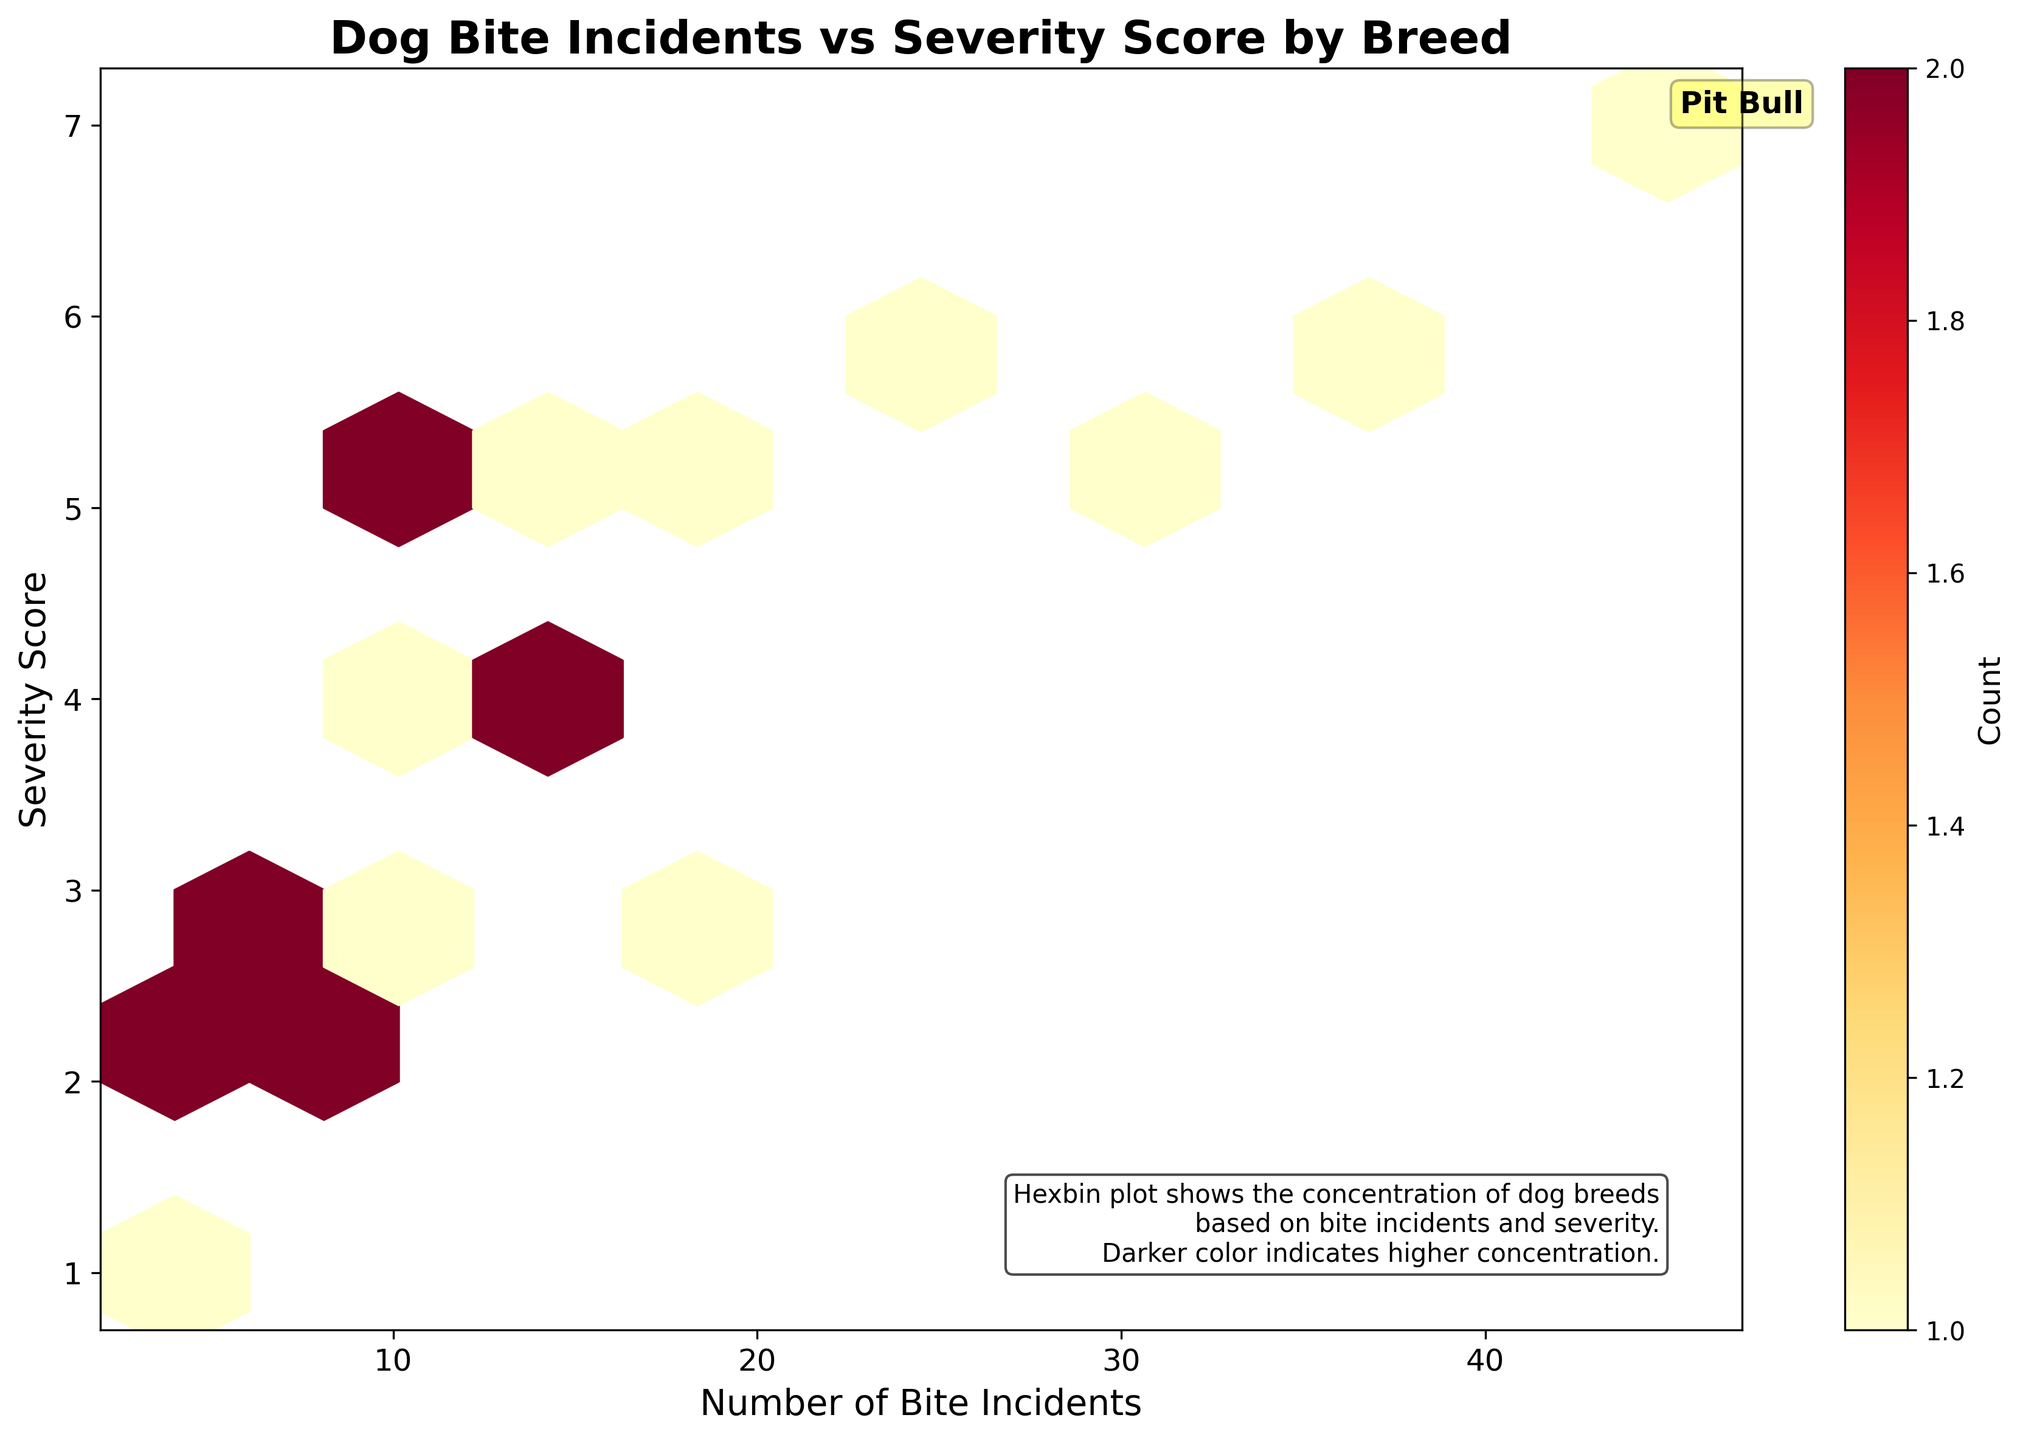what is the title of the plot? The title of the plot is displayed at the top of the figure in bold font. It reads "Dog Bite Incidents vs Severity Score by Breed".
Answer: Dog Bite Incidents vs Severity Score by Breed How many hexagons are there in the grid? To determine the number of hexagons, we note that the hexbin grid size parameter is set to 10, which is a typical dimension for small hexbin plots.
Answer: 10x10 grid Which breed is specifically annotated in the plot? The annotation specifically points to the 'Pit Bull' breed. The annotation includes the text 'Pit Bull' and is placed near its data point to highlight its significant bite incidents and severity score.
Answer: Pit Bull How many dog breeds have a severity score of 5 and higher? By inspecting the hexbin plot, focus on the y-axis to identify breeds with a severity score of 5 and higher. Count the data points within hexagons at or above that level.
Answer: 8 breeds What is the highest number of bite incidents recorded by any breed? Look at the x-axis (Number of Bite Incidents) and identify the furthest data point to the right. The maximum value corresponds to the 'Pit Bull' breed with 45 incidents.
Answer: 45 How does the number of bite incidents by Labradors compare to Pit Bulls? Locate both Labradors and Pit Bulls on the hexbin plot. Labradors have 30 bite incidents, and Pit Bulls have 45. Compare these two figures.
Answer: Labradors have fewer bite incidents compared to Pit Bulls What is the average severity score among breeds with 10 or more bite incidents? First, identify the breeds with 10 or more bite incidents: Pit Bull, Labrador Retriever, German Shepherd, Rottweiler, Chihuahua, Boxer, and Great Dane. Sum their severity scores (7 + 5 + 6 + 6 + 3 + 4 + 5 = 36) and divide by the number of breeds (36 / 7).
Answer: 5.14 Which breeds have a severity score that exceeds that of the Labrador Retriever? The severity score of the Labrador Retriever is 5. Compare it with other breeds' severity scores: Pit Bull (7), German Shepherd (6), Rottweiler (6). These exceeding scores suggest that they have more severe incidents.
Answer: Pit Bull, German Shepherd, Rottweiler What does the color intensity in hexagons indicate? The color intensity (darker color) represents the number of data points in that area, showing where bite incidents and severity scores cluster for various breeds.
Answer: Higher concentration of data points Do smaller breeds like Chihuahuas appear to have higher or lower severity scores? By looking at the corresponding hexagon for Chihuahuas on the plot, we see they have a lower middle-range severity score while having 20 incidents.
Answer: Lower/mid-range severity scores 